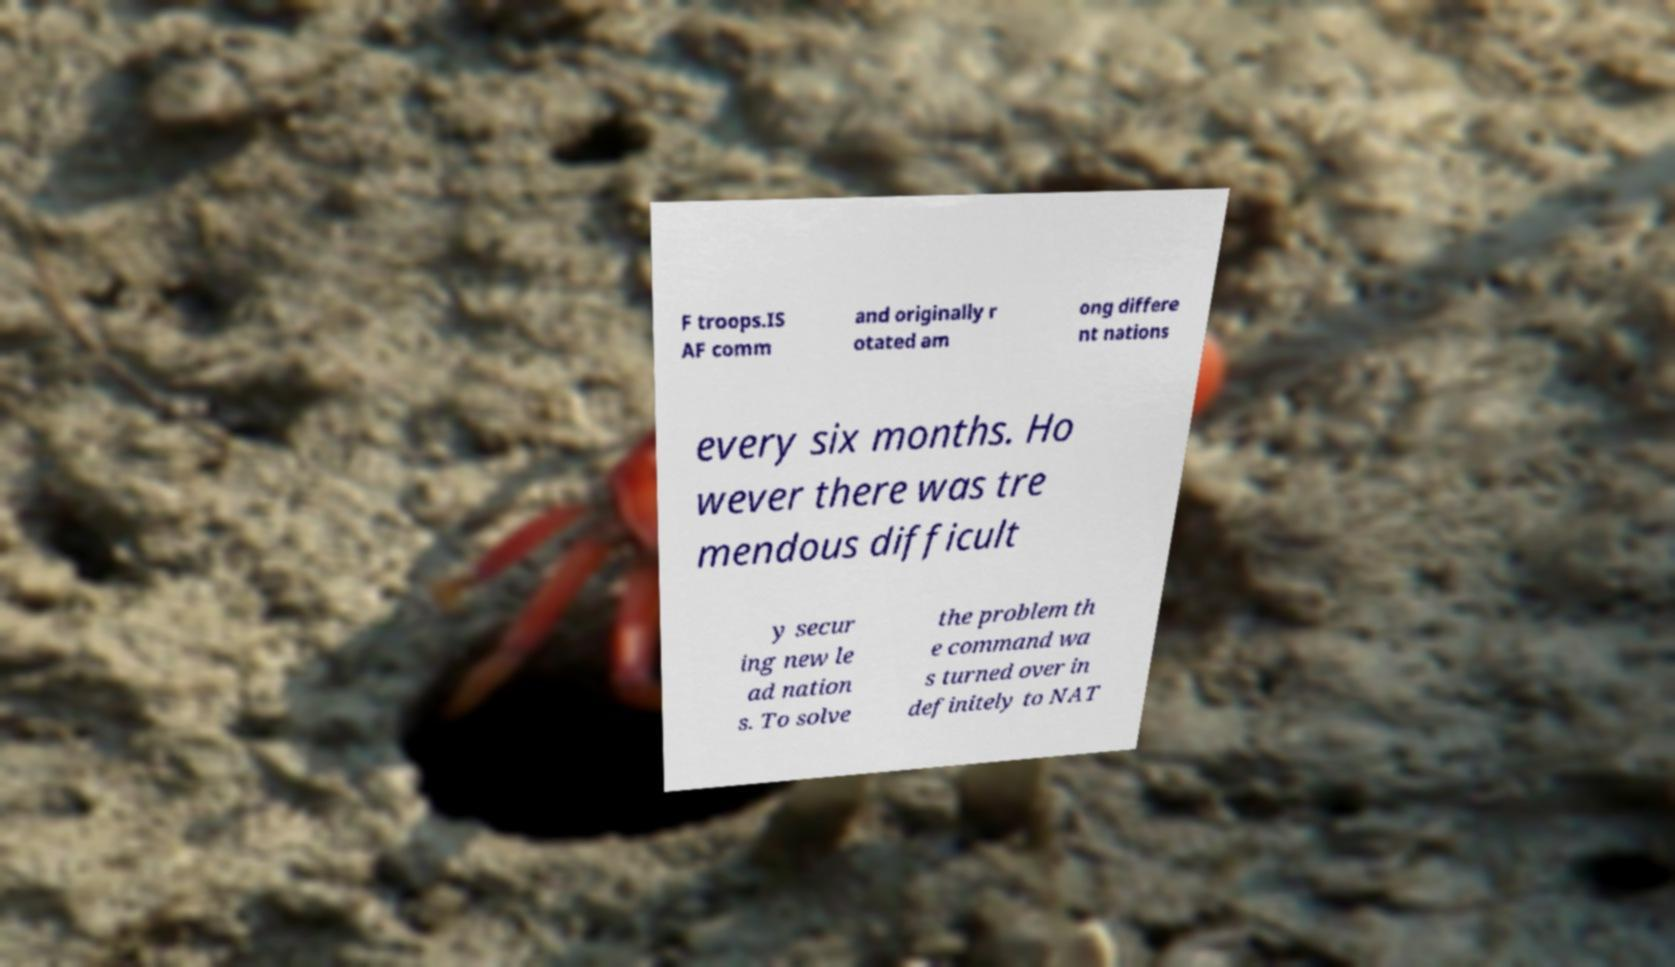Please identify and transcribe the text found in this image. F troops.IS AF comm and originally r otated am ong differe nt nations every six months. Ho wever there was tre mendous difficult y secur ing new le ad nation s. To solve the problem th e command wa s turned over in definitely to NAT 